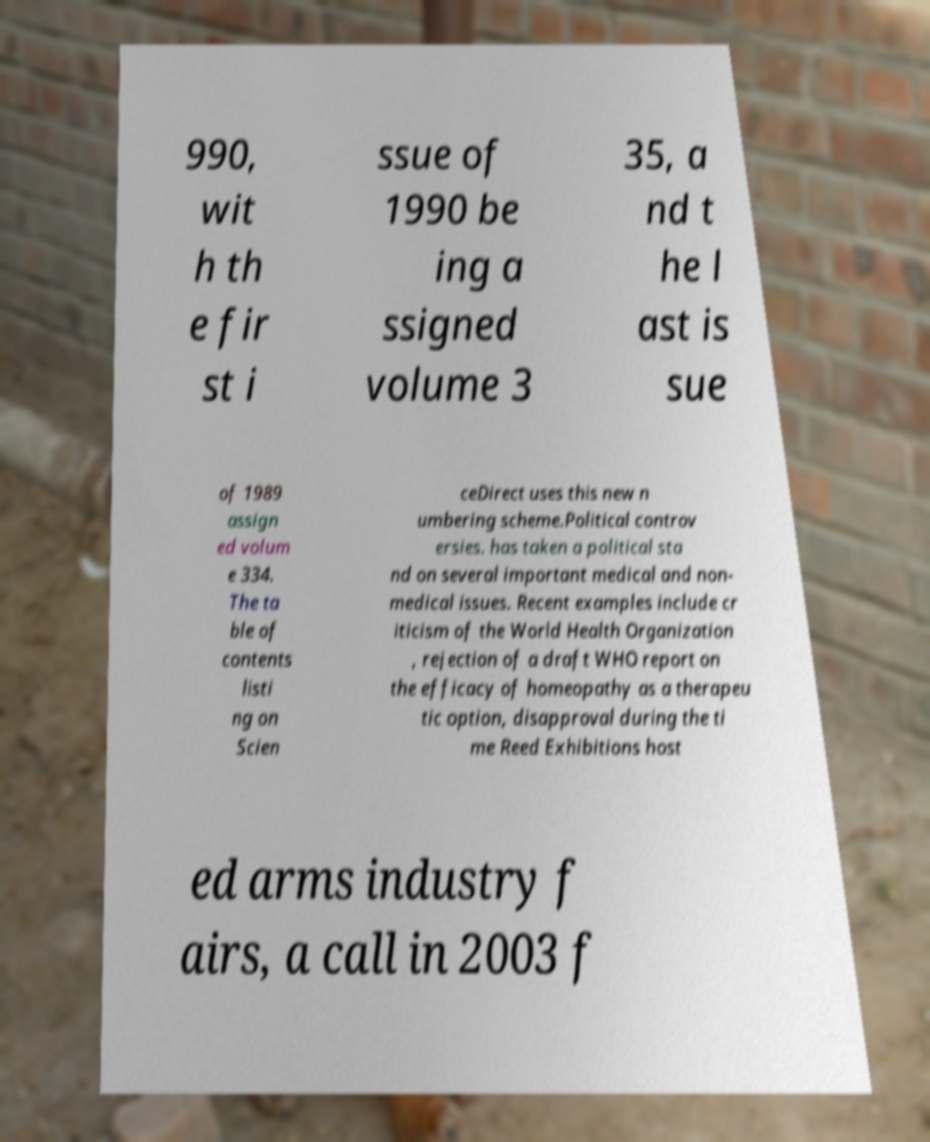Please identify and transcribe the text found in this image. 990, wit h th e fir st i ssue of 1990 be ing a ssigned volume 3 35, a nd t he l ast is sue of 1989 assign ed volum e 334. The ta ble of contents listi ng on Scien ceDirect uses this new n umbering scheme.Political controv ersies. has taken a political sta nd on several important medical and non- medical issues. Recent examples include cr iticism of the World Health Organization , rejection of a draft WHO report on the efficacy of homeopathy as a therapeu tic option, disapproval during the ti me Reed Exhibitions host ed arms industry f airs, a call in 2003 f 